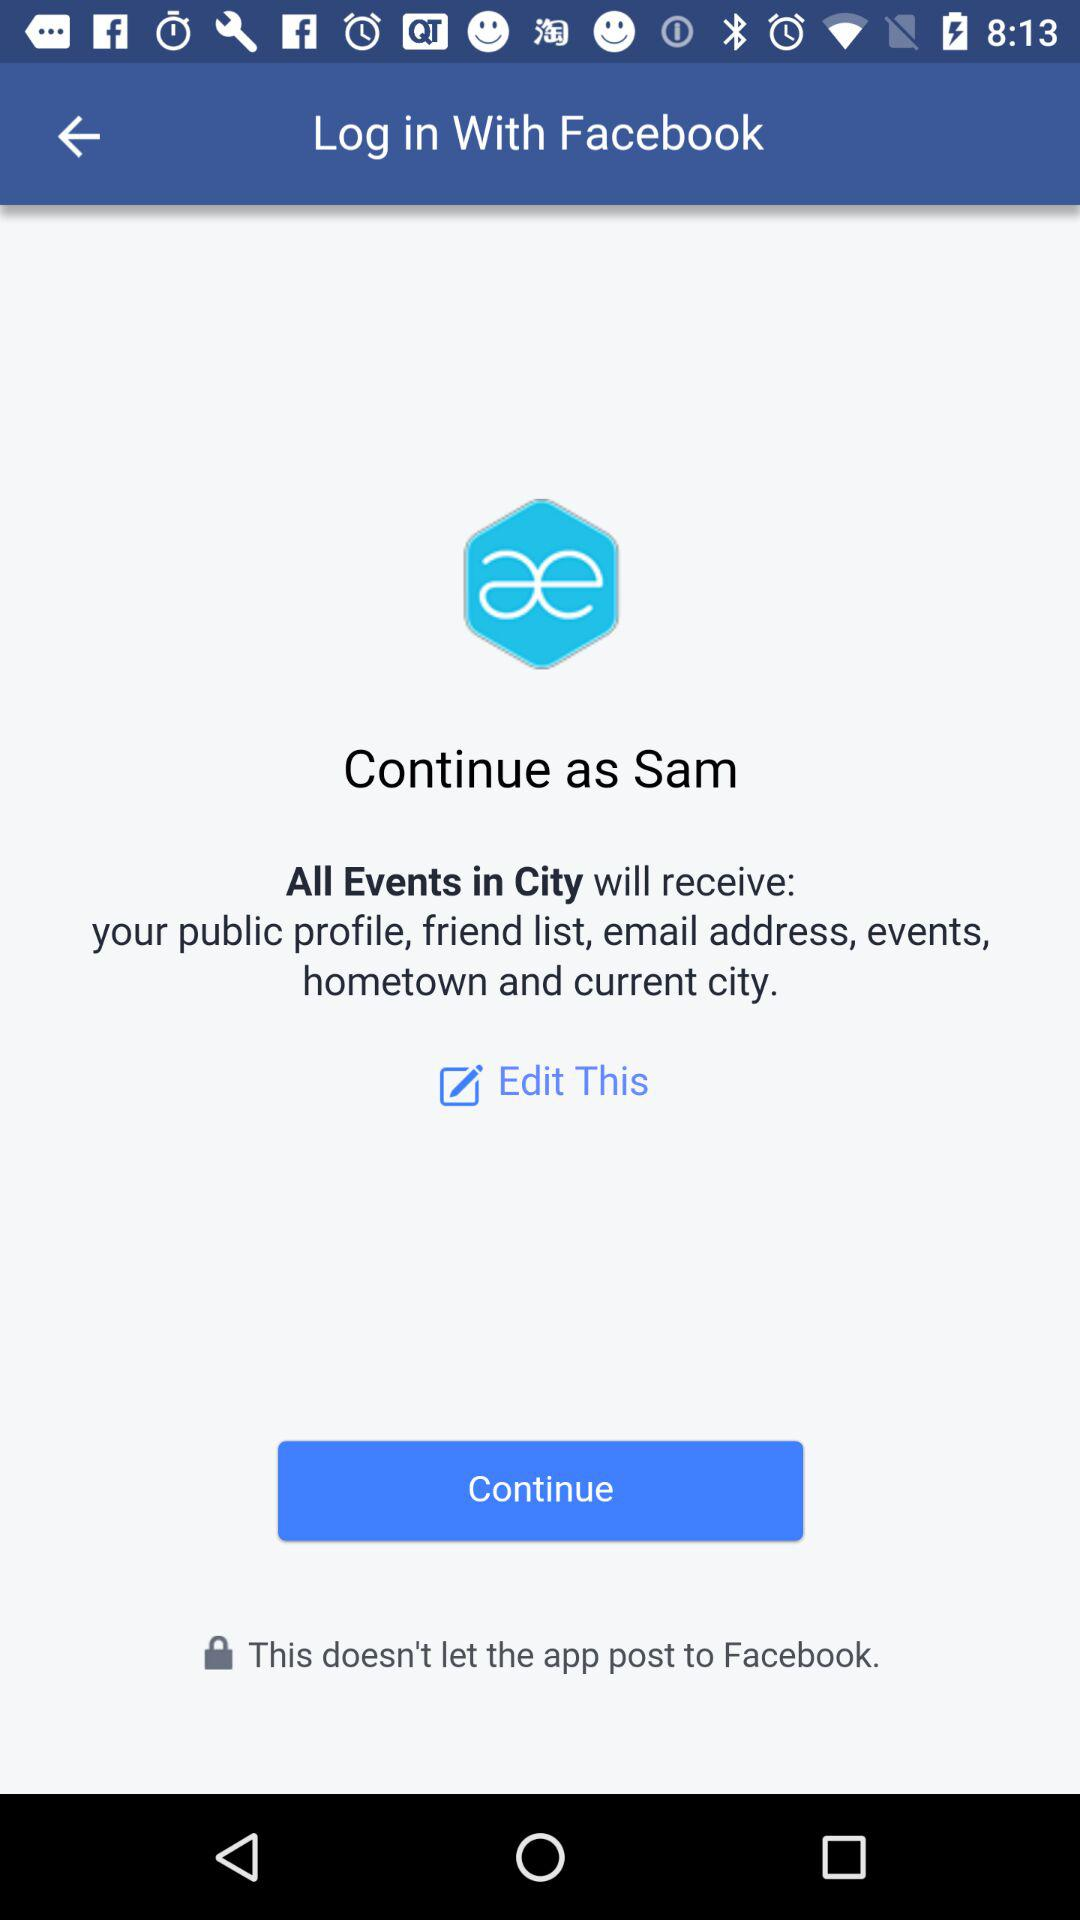What information will "All Events in City" receive?
Answer the question using a single word or phrase. "All Events in City" will receive information about "your public profile, friend list, email address, events, hometown, and current city." 